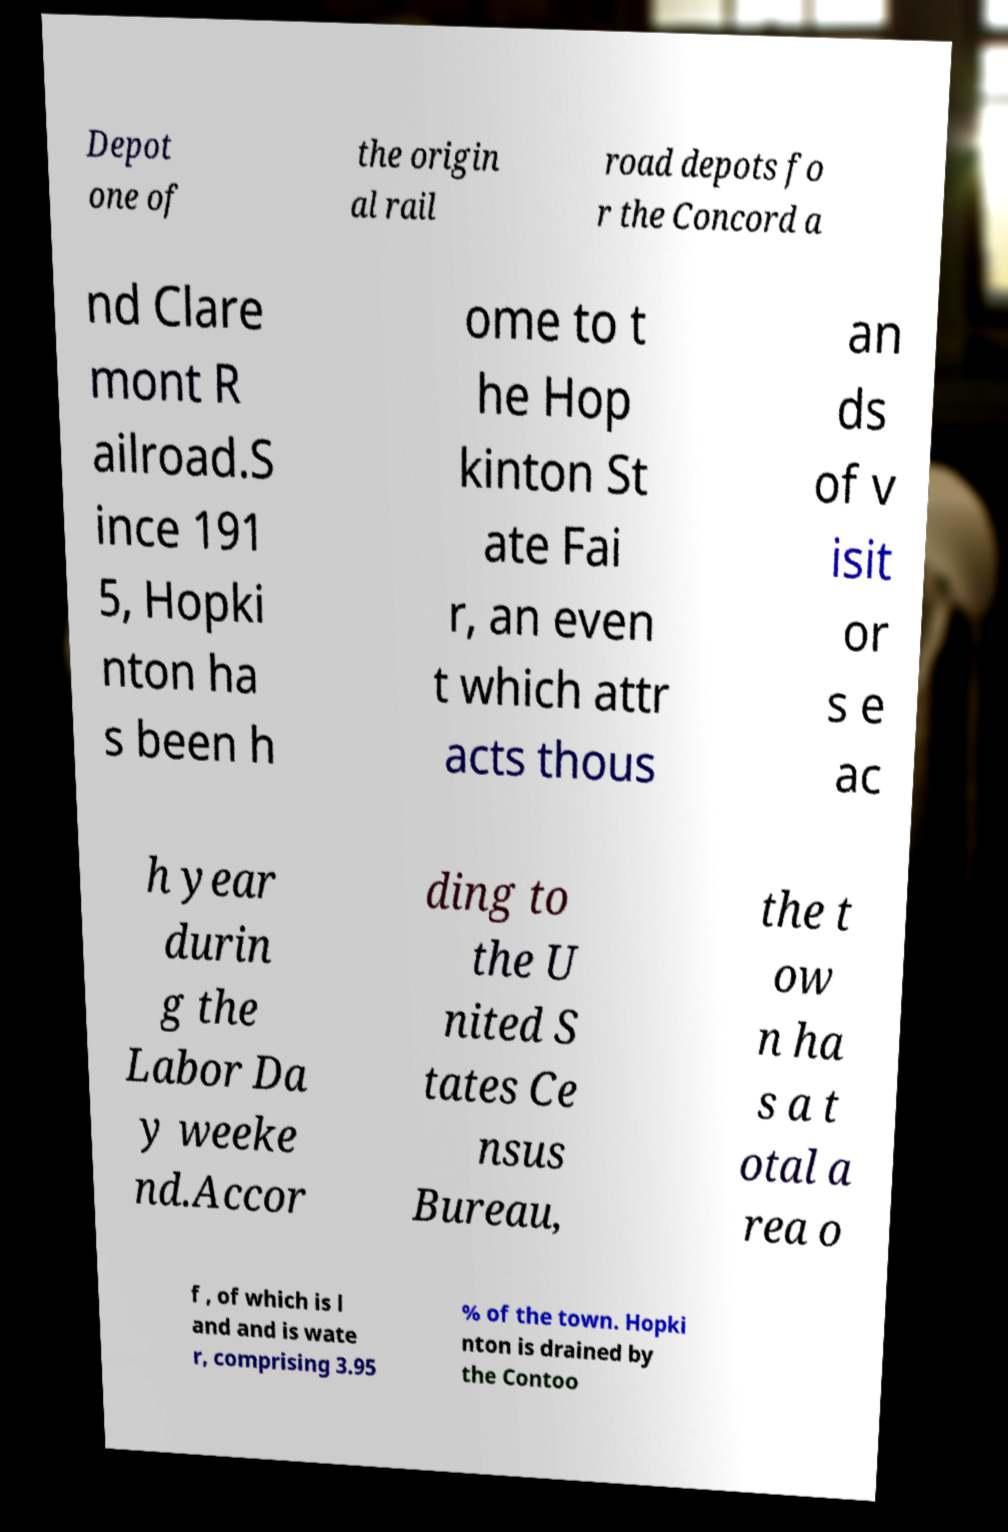Please identify and transcribe the text found in this image. Depot one of the origin al rail road depots fo r the Concord a nd Clare mont R ailroad.S ince 191 5, Hopki nton ha s been h ome to t he Hop kinton St ate Fai r, an even t which attr acts thous an ds of v isit or s e ac h year durin g the Labor Da y weeke nd.Accor ding to the U nited S tates Ce nsus Bureau, the t ow n ha s a t otal a rea o f , of which is l and and is wate r, comprising 3.95 % of the town. Hopki nton is drained by the Contoo 